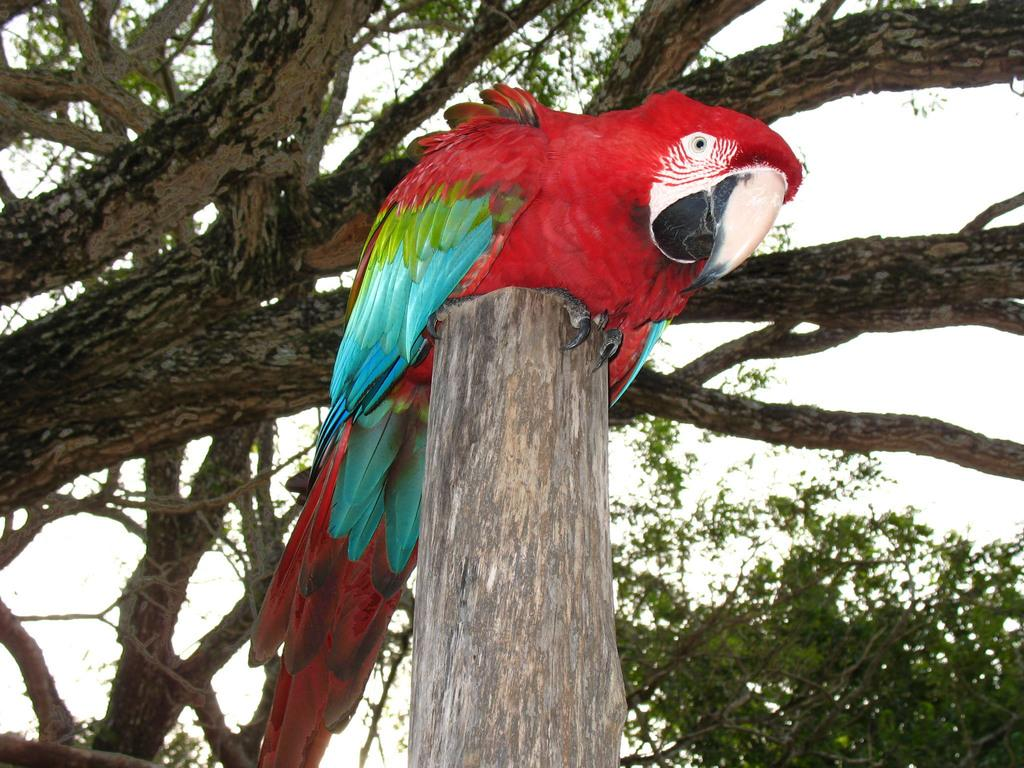What type of bird is in the image? There is a red color parrot in the image. Where is the parrot located in the image? The parrot is sitting in the middle of the image. What can be seen in the background of the image? There are green color trees in the background of the image. What is visible above the trees in the image? The sky is visible in the image. How does the parrot's knee in the image? The parrot does not have knees, as it is a bird and does not have knees or any other body parts mentioned in the question. 